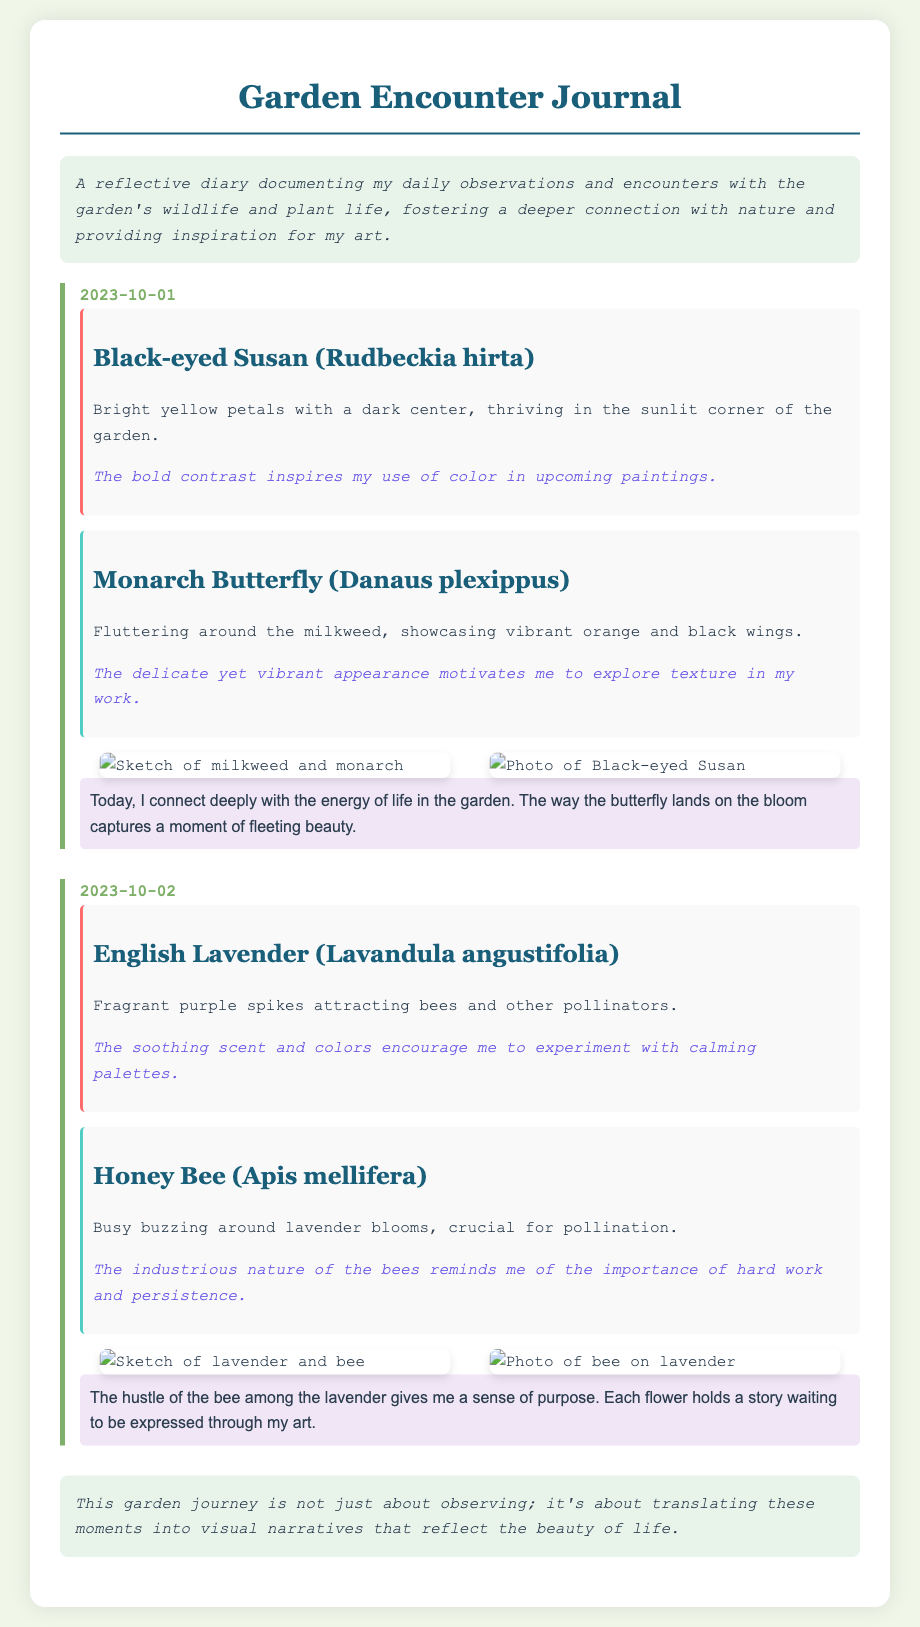What is the title of the journal? The title of the journal is found in the heading of the document.
Answer: Garden Encounter Journal What date is recorded for the observation of the Black-eyed Susan? The date for this observation is mentioned along with the entry details.
Answer: 2023-10-01 What two species are observed on October 1st? The document lists both the flora and fauna observed on that date.
Answer: Black-eyed Susan and Monarch Butterfly What inspiration is derived from the Honey Bee observation? The inspiration is provided in a dedicated section for the Honey Bee.
Answer: Importance of hard work and persistence How many images accompany the entry for October 2nd? The number of images is indicated in the sketches-photos section of the entry.
Answer: Two What color are the petals of the English Lavender? The color of the lavender petals is described in the entry for that plant.
Answer: Purple What emotion does the artist express in their reflections for October 1st? The reflections convey the artist's feelings after observing the garden's wildlife.
Answer: Fleeting beauty What visual element is prominent in the sketches and photos layout? The photos are organized in a specific visual way to enhance presentation.
Answer: Flexibility/Alignment 